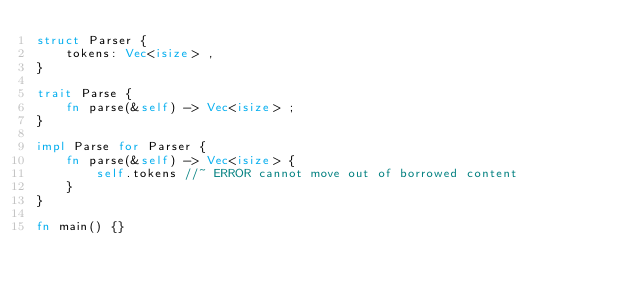Convert code to text. <code><loc_0><loc_0><loc_500><loc_500><_Rust_>struct Parser {
    tokens: Vec<isize> ,
}

trait Parse {
    fn parse(&self) -> Vec<isize> ;
}

impl Parse for Parser {
    fn parse(&self) -> Vec<isize> {
        self.tokens //~ ERROR cannot move out of borrowed content
    }
}

fn main() {}
</code> 